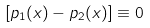<formula> <loc_0><loc_0><loc_500><loc_500>[ p _ { 1 } ( x ) - p _ { 2 } ( x ) ] \equiv 0</formula> 